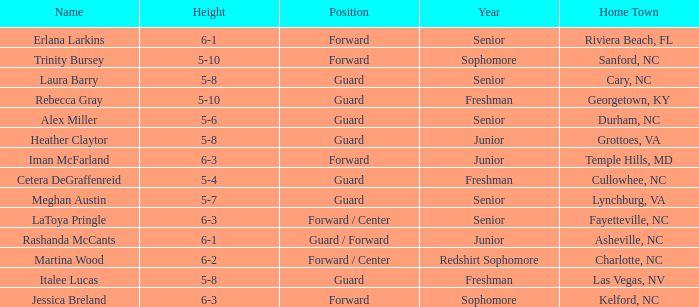What is the name of the guard from Cary, NC? Laura Barry. 